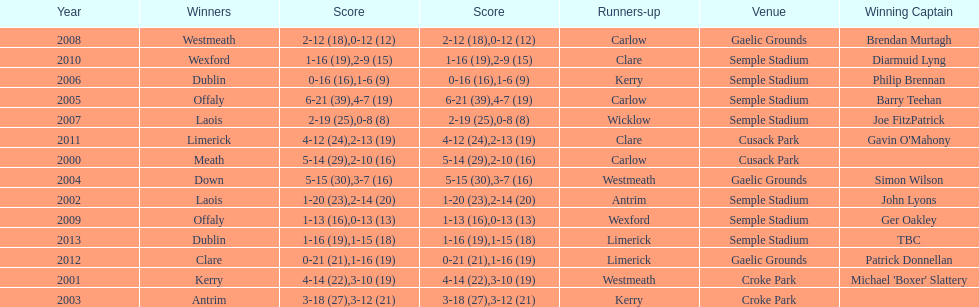Who was the winner after 2007? Laois. 